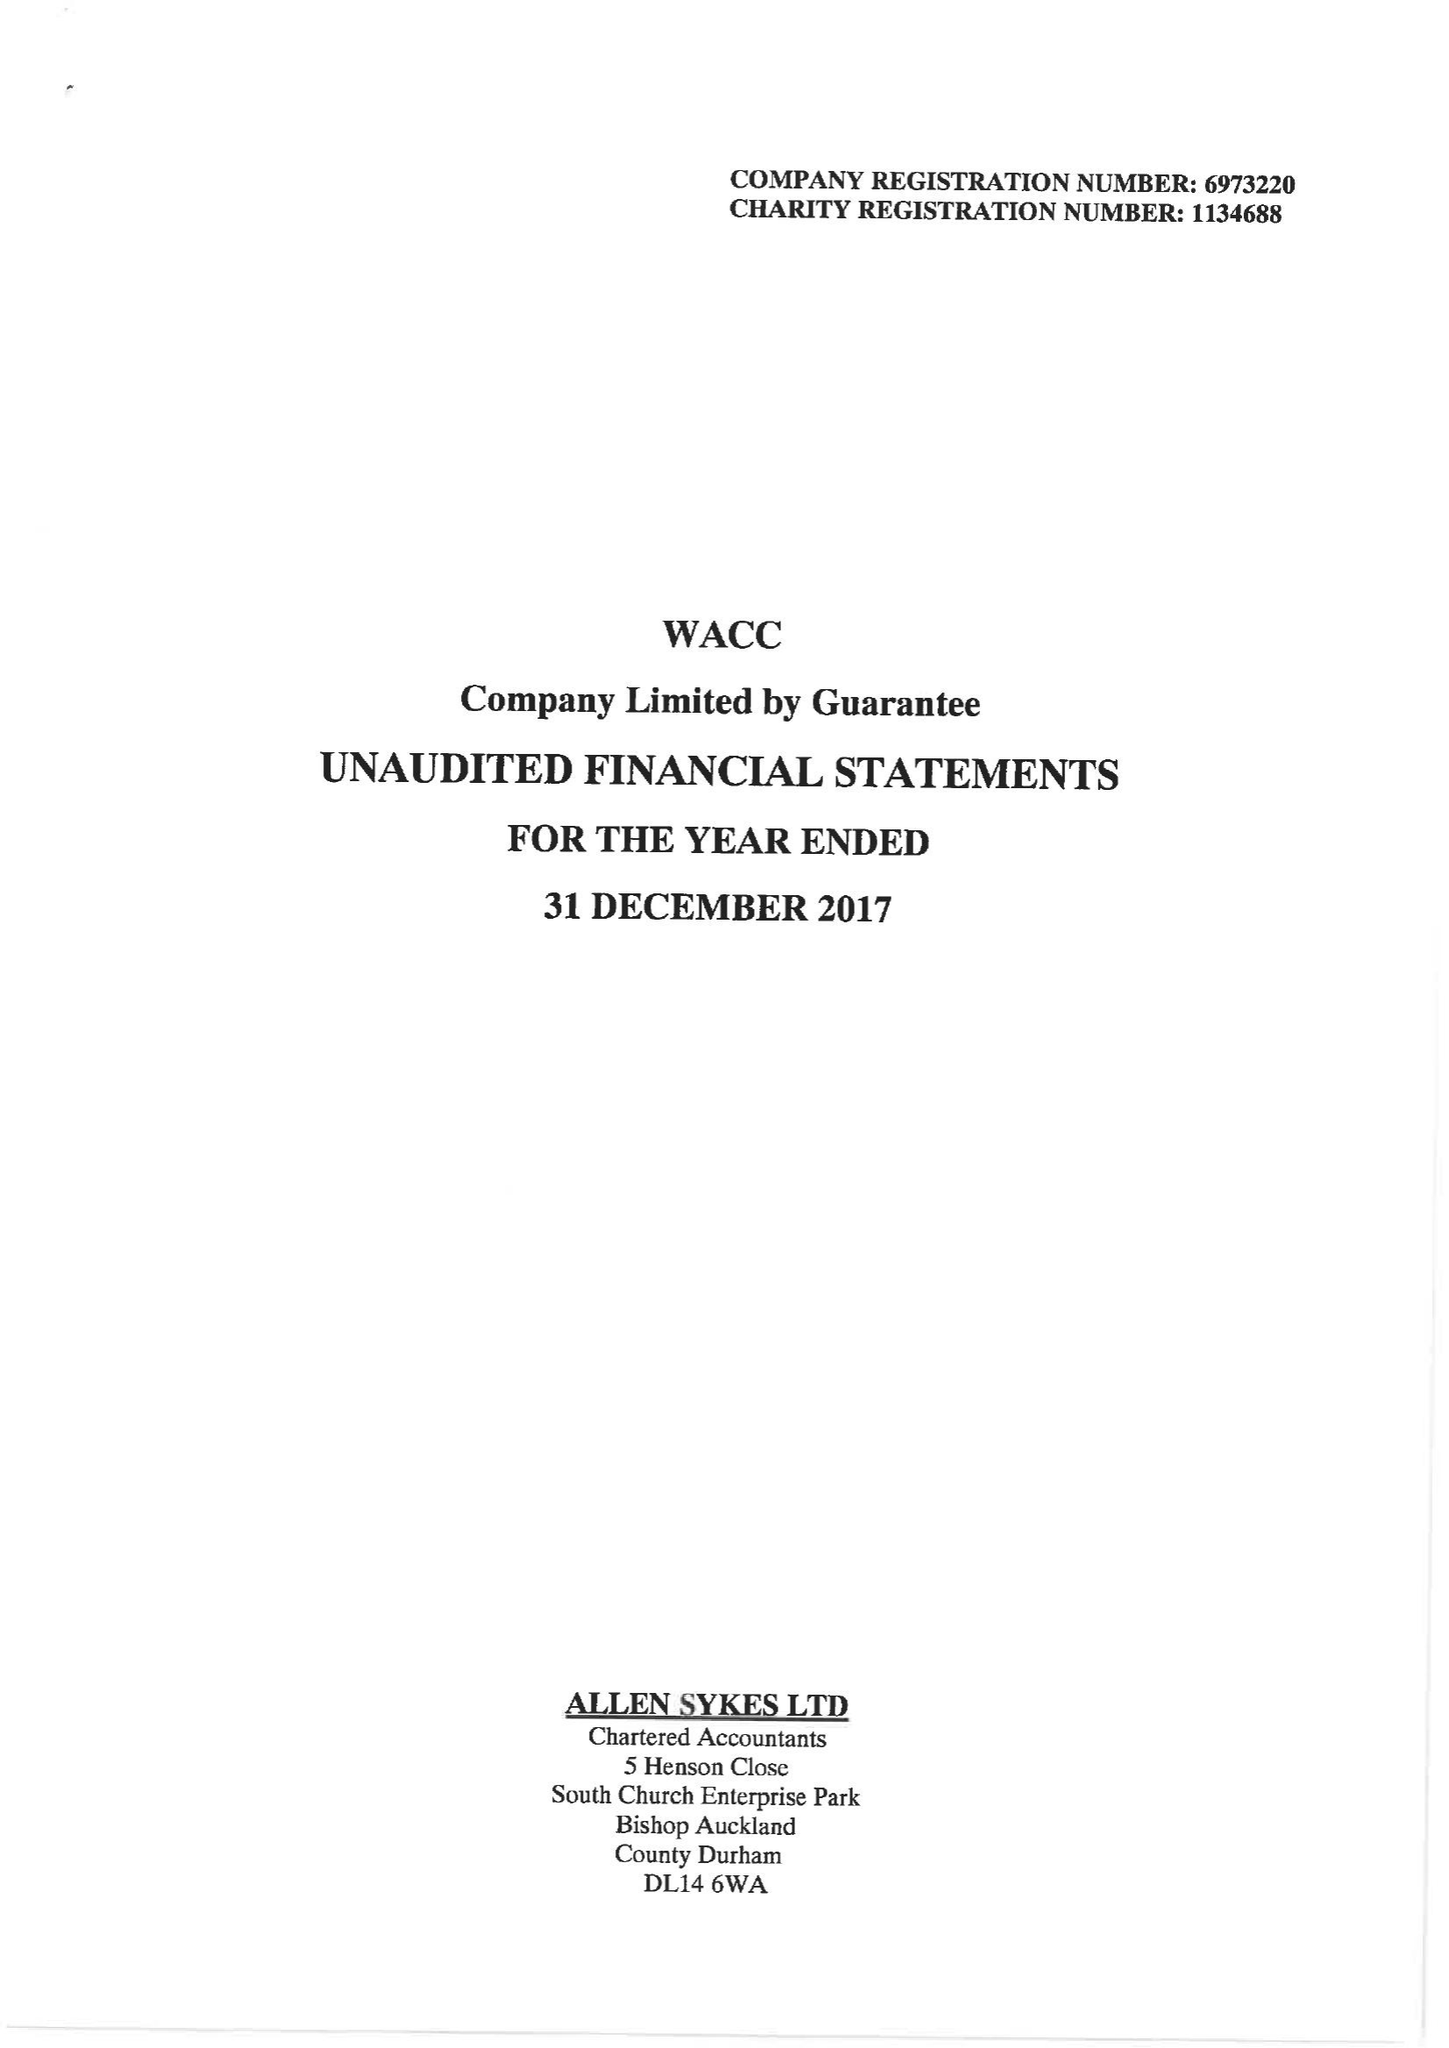What is the value for the income_annually_in_british_pounds?
Answer the question using a single word or phrase. 109743.00 